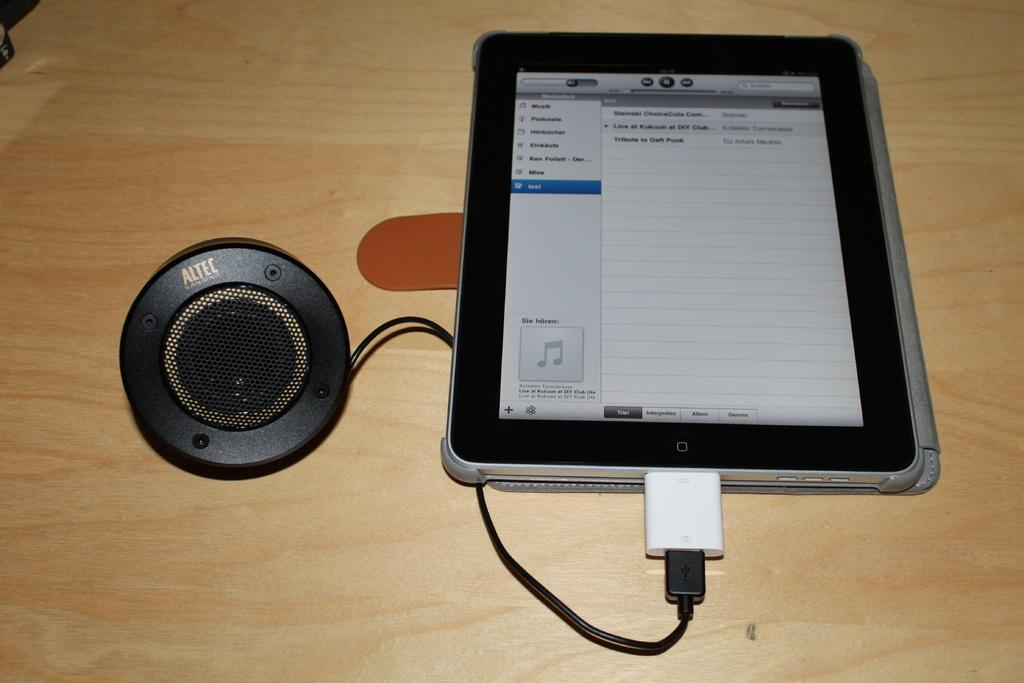What is the main object in the image with a cable? There is an object with a cable in the image. How is the object with a cable connected to another element? The object is connected to a tab. What type of furniture is present at the bottom of the image? There is a table at the bottom of the image. What type of stew is being served on the table in the image? There is no stew present in the image; it only features an object with a cable, a tab, and a table. 